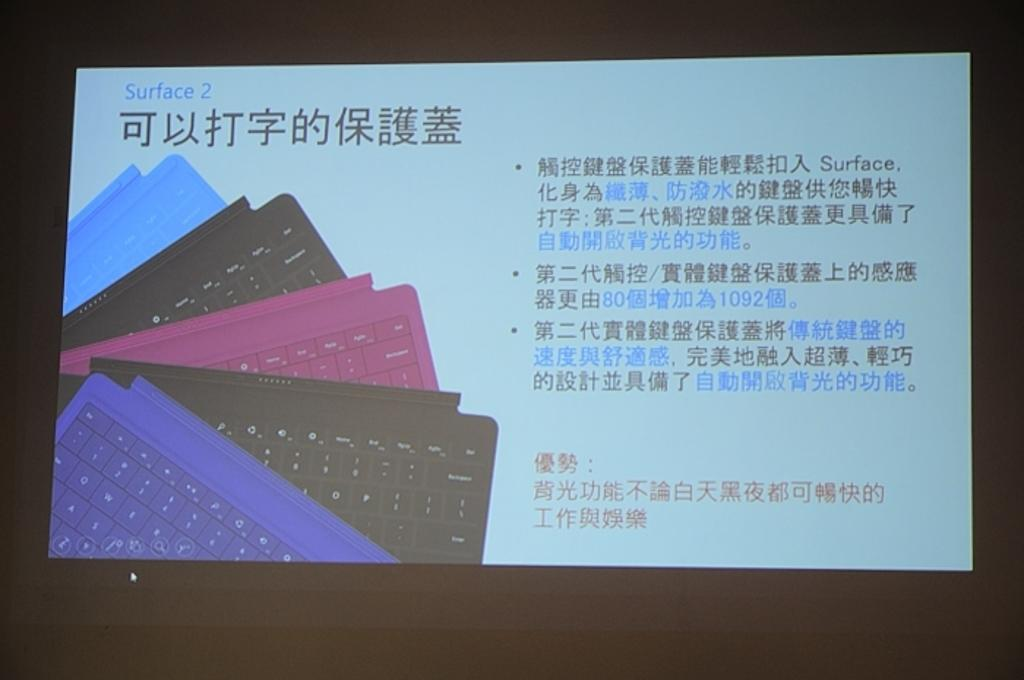<image>
Present a compact description of the photo's key features. A screen with pictures of keyboards on it is labeled Surface 2 in the upper left corner. 